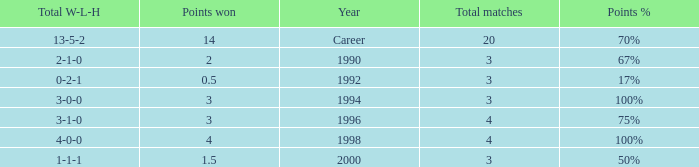Can you tell me the lowest Points won that has the Total matches of 4, and the Total W-L-H of 4-0-0? 4.0. 